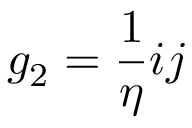<formula> <loc_0><loc_0><loc_500><loc_500>g _ { 2 } = { \frac { 1 } { \eta } } i j</formula> 